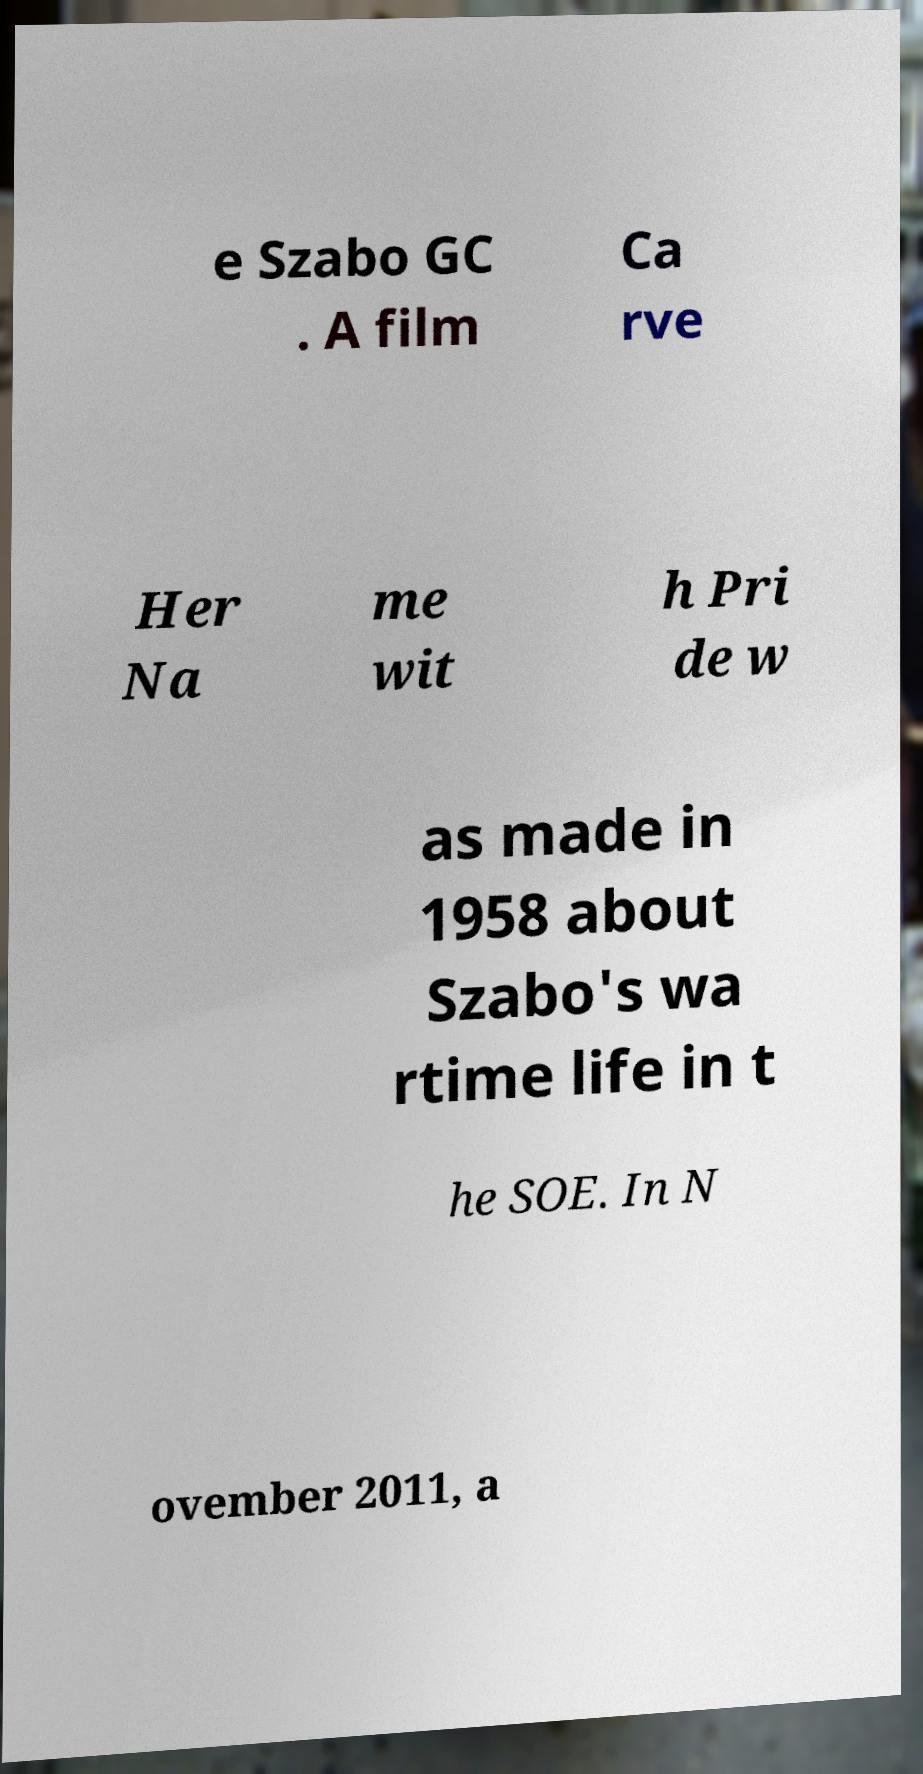Can you read and provide the text displayed in the image?This photo seems to have some interesting text. Can you extract and type it out for me? e Szabo GC . A film Ca rve Her Na me wit h Pri de w as made in 1958 about Szabo's wa rtime life in t he SOE. In N ovember 2011, a 